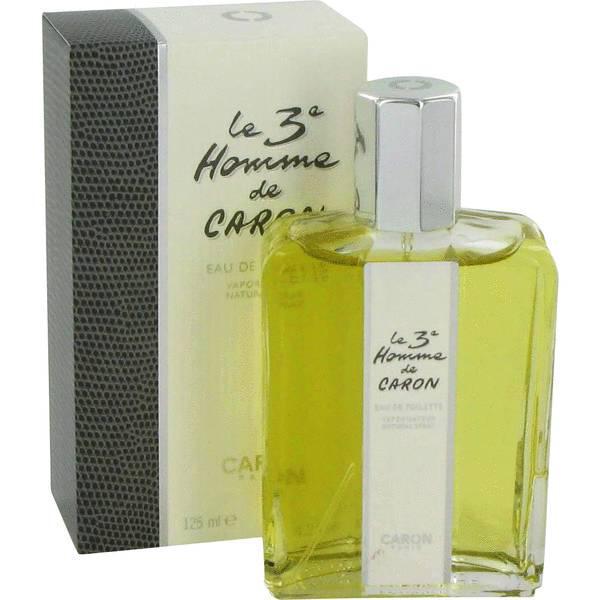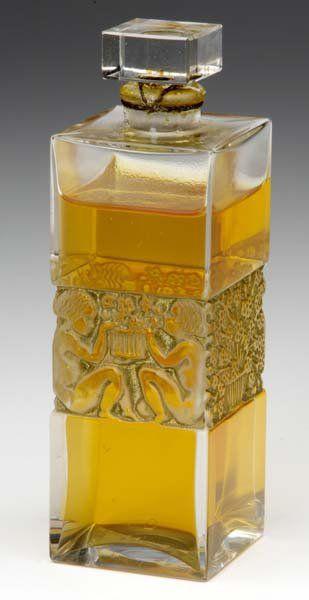The first image is the image on the left, the second image is the image on the right. Examine the images to the left and right. Is the description "There are at least five bottles of perfume." accurate? Answer yes or no. No. The first image is the image on the left, the second image is the image on the right. Given the left and right images, does the statement "There are at least four bottles of perfume." hold true? Answer yes or no. No. 